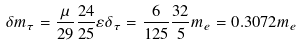Convert formula to latex. <formula><loc_0><loc_0><loc_500><loc_500>\delta m _ { \tau } = \frac { \mu } { 2 9 } \frac { 2 4 } { 2 5 } \varepsilon \delta _ { \tau } = \frac { 6 } { 1 2 5 } \frac { 3 2 } { 5 } m _ { e } = 0 . 3 0 7 2 m _ { e }</formula> 